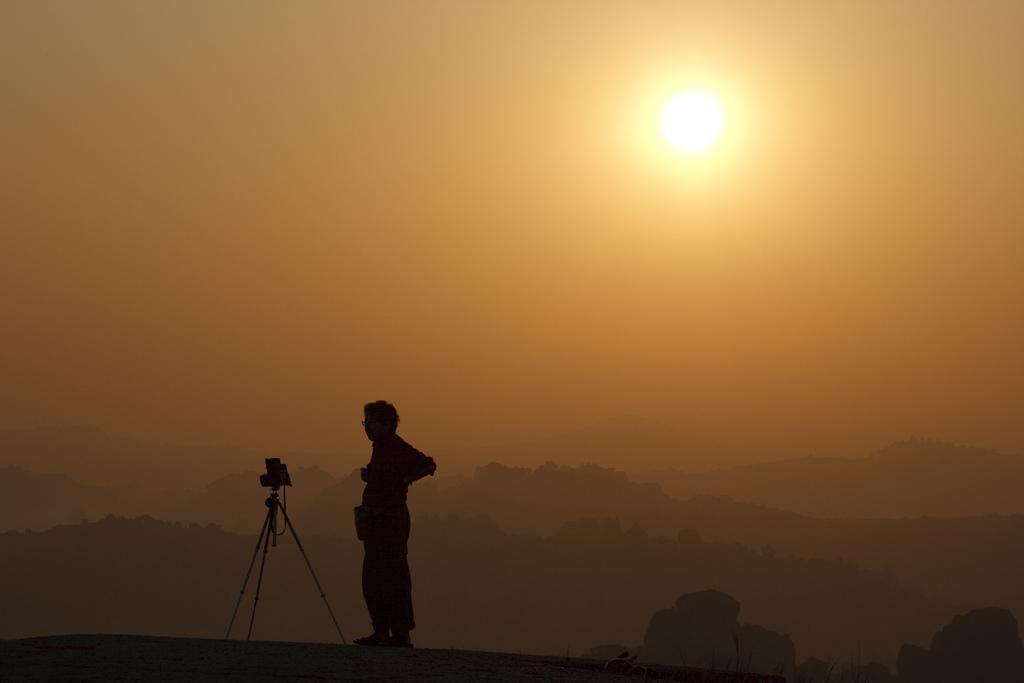Describe this image in one or two sentences. In this picture we can see a person is standing and on the left side of the person there is a camera on the tripod stand. Behind the person there are hills and the sun in the sky. 